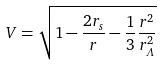<formula> <loc_0><loc_0><loc_500><loc_500>V = \sqrt { 1 - \frac { 2 r _ { s } } { r } - \frac { 1 } { 3 } \frac { r ^ { 2 } } { r _ { \varLambda } ^ { 2 } } }</formula> 